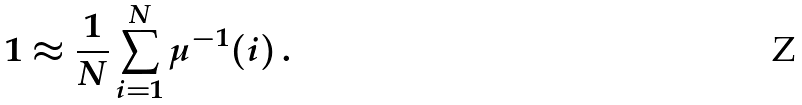<formula> <loc_0><loc_0><loc_500><loc_500>1 \approx \frac { 1 } { N } \sum _ { i = 1 } ^ { N } \mu ^ { - 1 } ( i ) \, .</formula> 